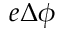Convert formula to latex. <formula><loc_0><loc_0><loc_500><loc_500>e \Delta \phi</formula> 